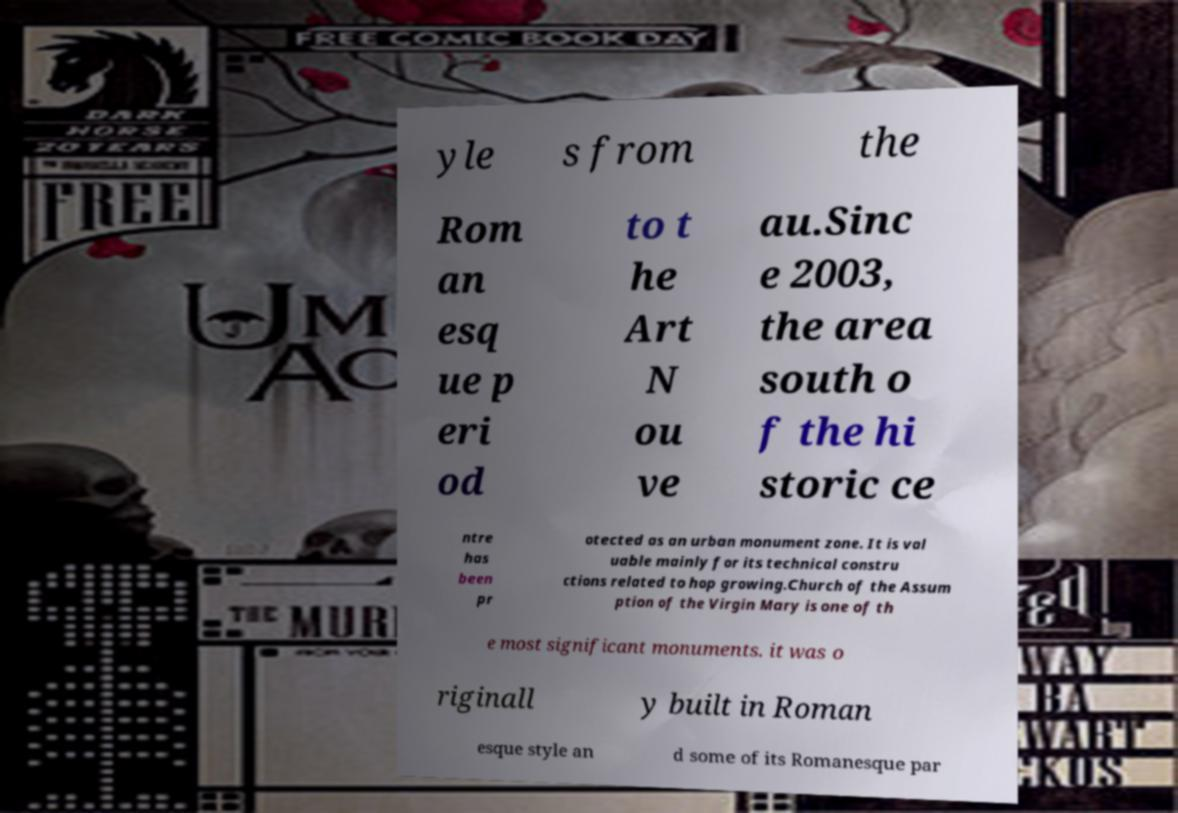For documentation purposes, I need the text within this image transcribed. Could you provide that? yle s from the Rom an esq ue p eri od to t he Art N ou ve au.Sinc e 2003, the area south o f the hi storic ce ntre has been pr otected as an urban monument zone. It is val uable mainly for its technical constru ctions related to hop growing.Church of the Assum ption of the Virgin Mary is one of th e most significant monuments. it was o riginall y built in Roman esque style an d some of its Romanesque par 